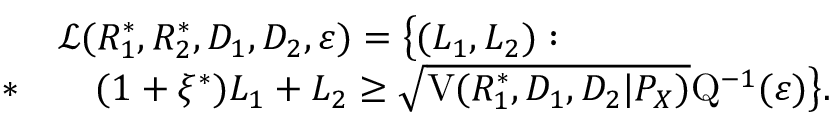Convert formula to latex. <formula><loc_0><loc_0><loc_500><loc_500>\begin{array} { r l } & { \mathcal { L } ( R _ { 1 } ^ { * } , R _ { 2 } ^ { * } , D _ { 1 } , D _ { 2 } , \varepsilon ) = \left \{ ( L _ { 1 } , L _ { 2 } ) \colon } \\ { * } & { \quad ( 1 + \xi ^ { * } ) L _ { 1 } + L _ { 2 } \geq \sqrt { V ( R _ { 1 } ^ { * } , D _ { 1 } , D _ { 2 } | P _ { X } ) } Q ^ { - 1 } ( \varepsilon ) \right \} . } \end{array}</formula> 